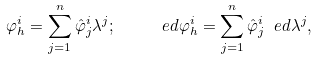<formula> <loc_0><loc_0><loc_500><loc_500>\varphi ^ { i } _ { h } = \sum ^ { n } _ { j = 1 } \hat { \varphi } ^ { i } _ { j } \lambda ^ { j } ; \quad \ e d \varphi ^ { i } _ { h } = \sum ^ { n } _ { j = 1 } \hat { \varphi } ^ { i } _ { j } \ e d \lambda ^ { j } ,</formula> 